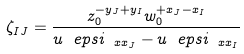Convert formula to latex. <formula><loc_0><loc_0><loc_500><loc_500>\zeta _ { I J } = \frac { z _ { 0 } ^ { - y _ { J } + y _ { I } } w _ { 0 } ^ { + x _ { J } - x _ { I } } } { u ^ { \ } e p s i _ { \ x x _ { J } } - u ^ { \ } e p s i _ { \ x x _ { I } } }</formula> 